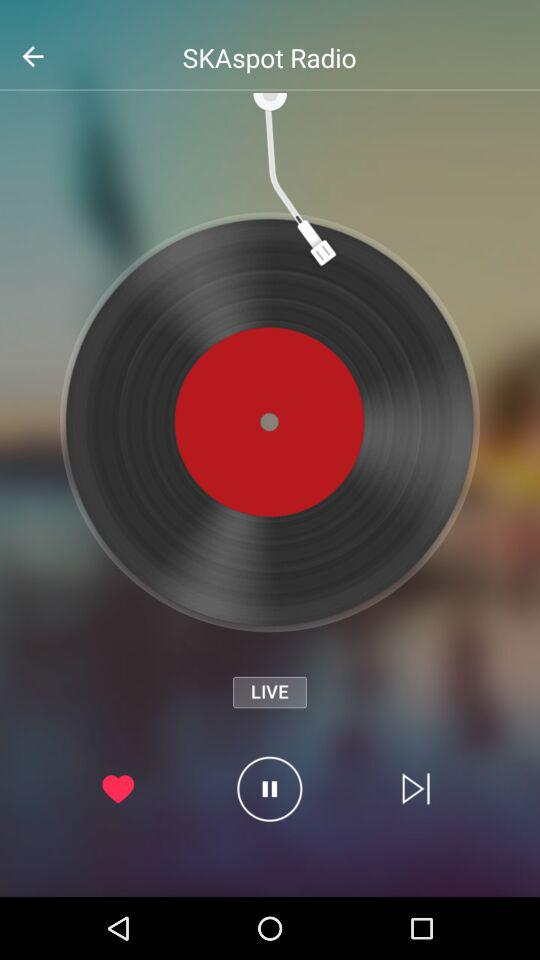What is the name of the application? The name of the application is "SKAspot Radio". 